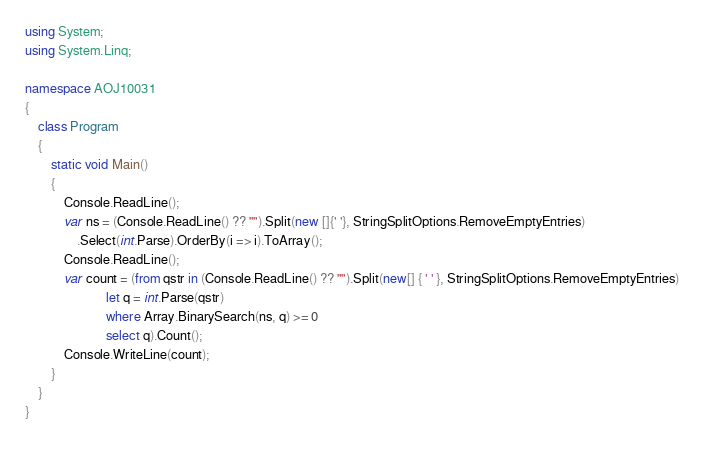<code> <loc_0><loc_0><loc_500><loc_500><_C#_>using System;
using System.Linq;

namespace AOJ10031
{
    class Program
    {
        static void Main()
        {
            Console.ReadLine();
            var ns = (Console.ReadLine() ?? "").Split(new []{' '}, StringSplitOptions.RemoveEmptyEntries)
                .Select(int.Parse).OrderBy(i => i).ToArray();
            Console.ReadLine();
            var count = (from qstr in (Console.ReadLine() ?? "").Split(new[] { ' ' }, StringSplitOptions.RemoveEmptyEntries)
                         let q = int.Parse(qstr)
                         where Array.BinarySearch(ns, q) >= 0
                         select q).Count();
            Console.WriteLine(count);
        }
    }
}</code> 